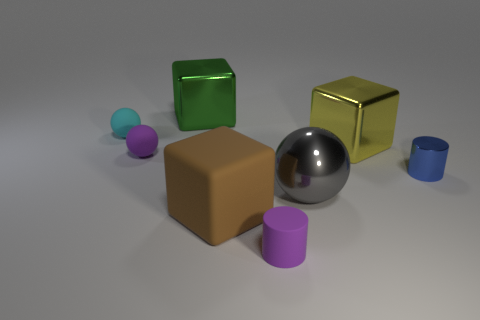Add 1 big brown cubes. How many objects exist? 9 Subtract all cylinders. How many objects are left? 6 Add 3 gray objects. How many gray objects are left? 4 Add 2 cyan metal cubes. How many cyan metal cubes exist? 2 Subtract 0 red cylinders. How many objects are left? 8 Subtract all shiny spheres. Subtract all large green cubes. How many objects are left? 6 